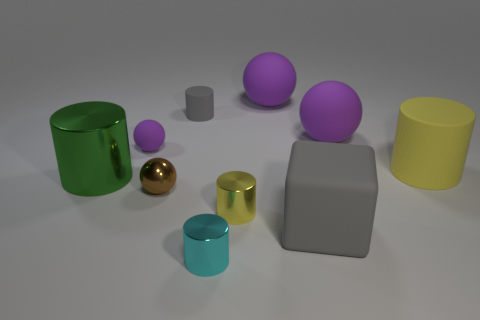Subtract all purple blocks. How many purple spheres are left? 3 Subtract 1 cylinders. How many cylinders are left? 4 Subtract all green cylinders. How many cylinders are left? 4 Subtract all purple cylinders. Subtract all purple balls. How many cylinders are left? 5 Subtract all spheres. How many objects are left? 6 Add 5 matte cylinders. How many matte cylinders are left? 7 Add 5 purple objects. How many purple objects exist? 8 Subtract 0 purple cubes. How many objects are left? 10 Subtract all small matte cylinders. Subtract all green metal cylinders. How many objects are left? 8 